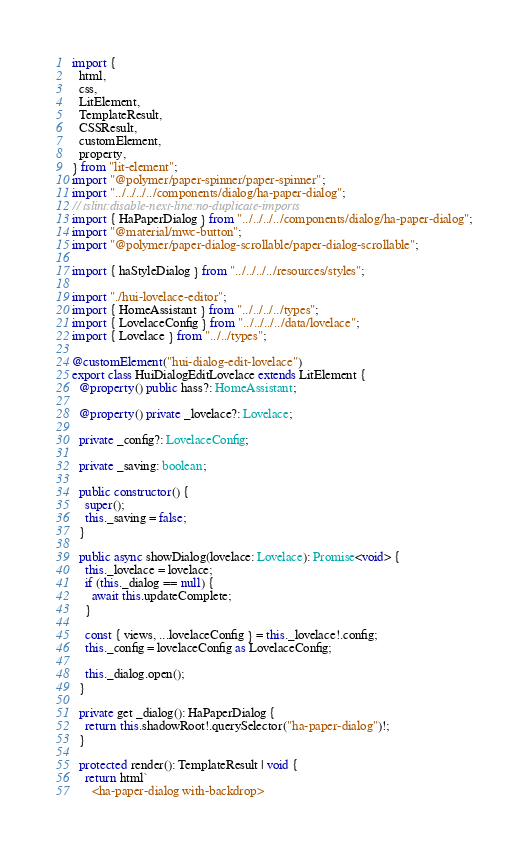Convert code to text. <code><loc_0><loc_0><loc_500><loc_500><_TypeScript_>import {
  html,
  css,
  LitElement,
  TemplateResult,
  CSSResult,
  customElement,
  property,
} from "lit-element";
import "@polymer/paper-spinner/paper-spinner";
import "../../../../components/dialog/ha-paper-dialog";
// tslint:disable-next-line:no-duplicate-imports
import { HaPaperDialog } from "../../../../components/dialog/ha-paper-dialog";
import "@material/mwc-button";
import "@polymer/paper-dialog-scrollable/paper-dialog-scrollable";

import { haStyleDialog } from "../../../../resources/styles";

import "./hui-lovelace-editor";
import { HomeAssistant } from "../../../../types";
import { LovelaceConfig } from "../../../../data/lovelace";
import { Lovelace } from "../../types";

@customElement("hui-dialog-edit-lovelace")
export class HuiDialogEditLovelace extends LitElement {
  @property() public hass?: HomeAssistant;

  @property() private _lovelace?: Lovelace;

  private _config?: LovelaceConfig;

  private _saving: boolean;

  public constructor() {
    super();
    this._saving = false;
  }

  public async showDialog(lovelace: Lovelace): Promise<void> {
    this._lovelace = lovelace;
    if (this._dialog == null) {
      await this.updateComplete;
    }

    const { views, ...lovelaceConfig } = this._lovelace!.config;
    this._config = lovelaceConfig as LovelaceConfig;

    this._dialog.open();
  }

  private get _dialog(): HaPaperDialog {
    return this.shadowRoot!.querySelector("ha-paper-dialog")!;
  }

  protected render(): TemplateResult | void {
    return html`
      <ha-paper-dialog with-backdrop></code> 